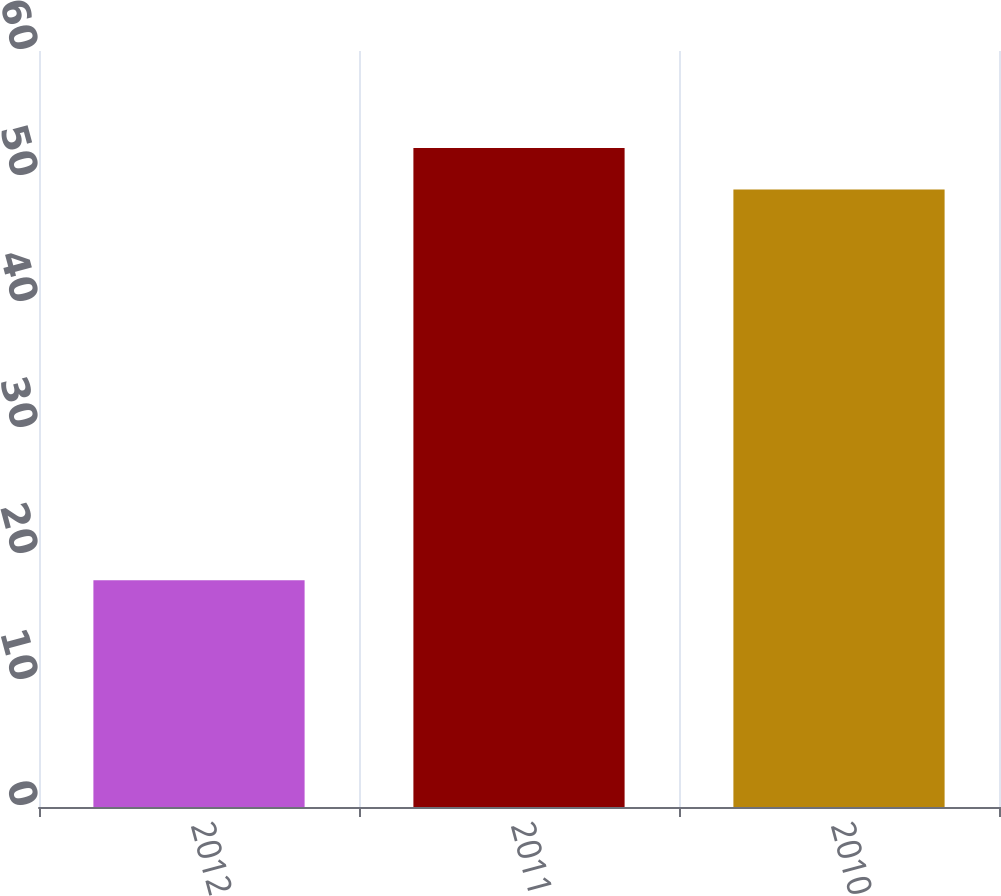Convert chart to OTSL. <chart><loc_0><loc_0><loc_500><loc_500><bar_chart><fcel>2012<fcel>2011<fcel>2010<nl><fcel>18<fcel>52.3<fcel>49<nl></chart> 